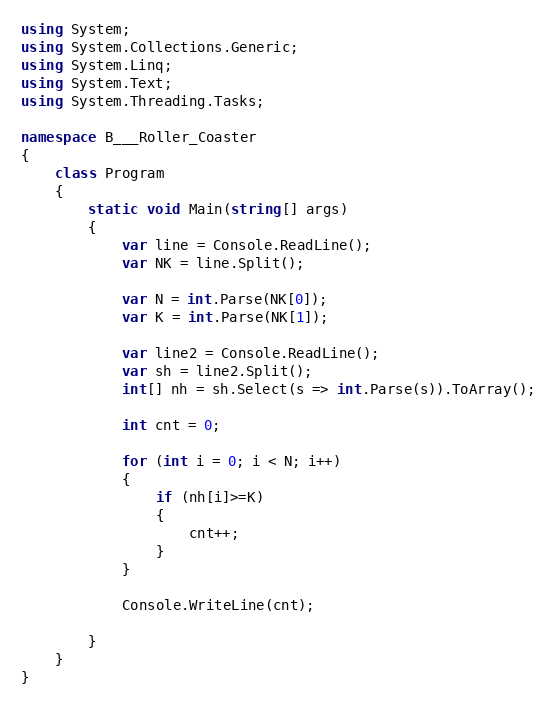Convert code to text. <code><loc_0><loc_0><loc_500><loc_500><_C#_>using System;
using System.Collections.Generic;
using System.Linq;
using System.Text;
using System.Threading.Tasks;

namespace B___Roller_Coaster
{
    class Program
    {
        static void Main(string[] args)
        {
            var line = Console.ReadLine();
            var NK = line.Split();

            var N = int.Parse(NK[0]);
            var K = int.Parse(NK[1]);

            var line2 = Console.ReadLine();
            var sh = line2.Split();
            int[] nh = sh.Select(s => int.Parse(s)).ToArray();

            int cnt = 0;

            for (int i = 0; i < N; i++)
            {
                if (nh[i]>=K)
                {
                    cnt++;
                }
            }

            Console.WriteLine(cnt);

        }
    }
}
</code> 